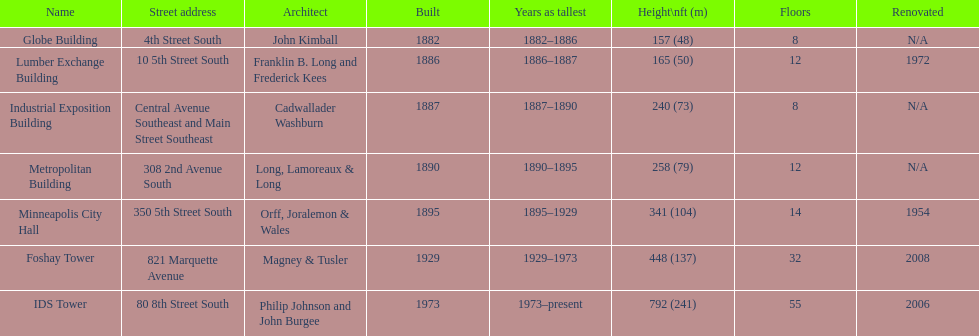How many floors does the foshay tower have? 32. Would you mind parsing the complete table? {'header': ['Name', 'Street address', 'Architect', 'Built', 'Years as tallest', 'Height\\nft (m)', 'Floors', 'Renovated'], 'rows': [['Globe Building', '4th Street South', 'John Kimball', '1882', '1882–1886', '157 (48)', '8', 'N/A'], ['Lumber Exchange Building', '10 5th Street South', 'Franklin B. Long and Frederick Kees', '1886', '1886–1887', '165 (50)', '12', '1972'], ['Industrial Exposition Building', 'Central Avenue Southeast and Main Street Southeast', 'Cadwallader Washburn', '1887', '1887–1890', '240 (73)', '8', 'N/A'], ['Metropolitan Building', '308 2nd Avenue South', 'Long, Lamoreaux & Long', '1890', '1890–1895', '258 (79)', '12', 'N/A'], ['Minneapolis City Hall', '350 5th Street South', 'Orff, Joralemon & Wales', '1895', '1895–1929', '341 (104)', '14', '1954'], ['Foshay Tower', '821 Marquette Avenue', 'Magney & Tusler', '1929', '1929–1973', '448 (137)', '32', '2008'], ['IDS Tower', '80 8th Street South', 'Philip Johnson and John Burgee', '1973', '1973–present', '792 (241)', '55', '2006']]} 